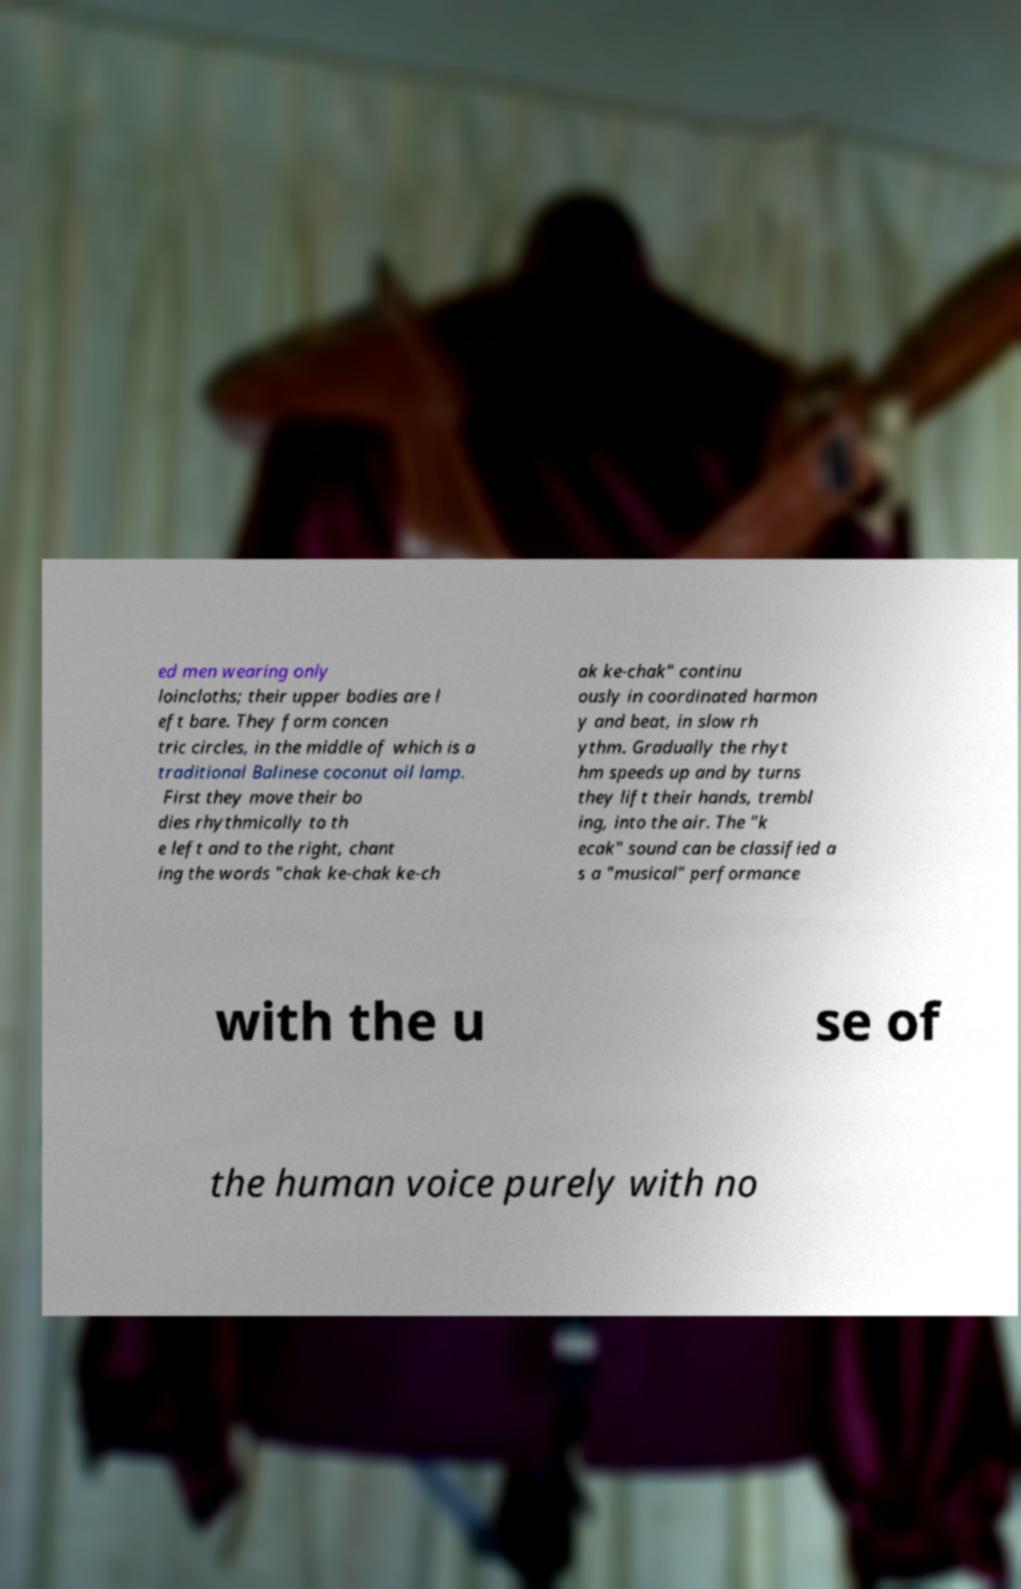I need the written content from this picture converted into text. Can you do that? ed men wearing only loincloths; their upper bodies are l eft bare. They form concen tric circles, in the middle of which is a traditional Balinese coconut oil lamp. First they move their bo dies rhythmically to th e left and to the right, chant ing the words "chak ke-chak ke-ch ak ke-chak" continu ously in coordinated harmon y and beat, in slow rh ythm. Gradually the rhyt hm speeds up and by turns they lift their hands, trembl ing, into the air. The "k ecak" sound can be classified a s a "musical" performance with the u se of the human voice purely with no 